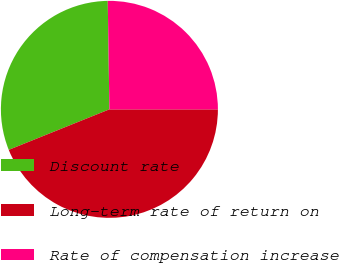Convert chart to OTSL. <chart><loc_0><loc_0><loc_500><loc_500><pie_chart><fcel>Discount rate<fcel>Long-term rate of return on<fcel>Rate of compensation increase<nl><fcel>30.85%<fcel>43.91%<fcel>25.24%<nl></chart> 